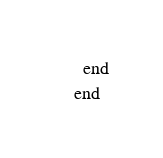Convert code to text. <code><loc_0><loc_0><loc_500><loc_500><_Elixir_>  end
end
</code> 